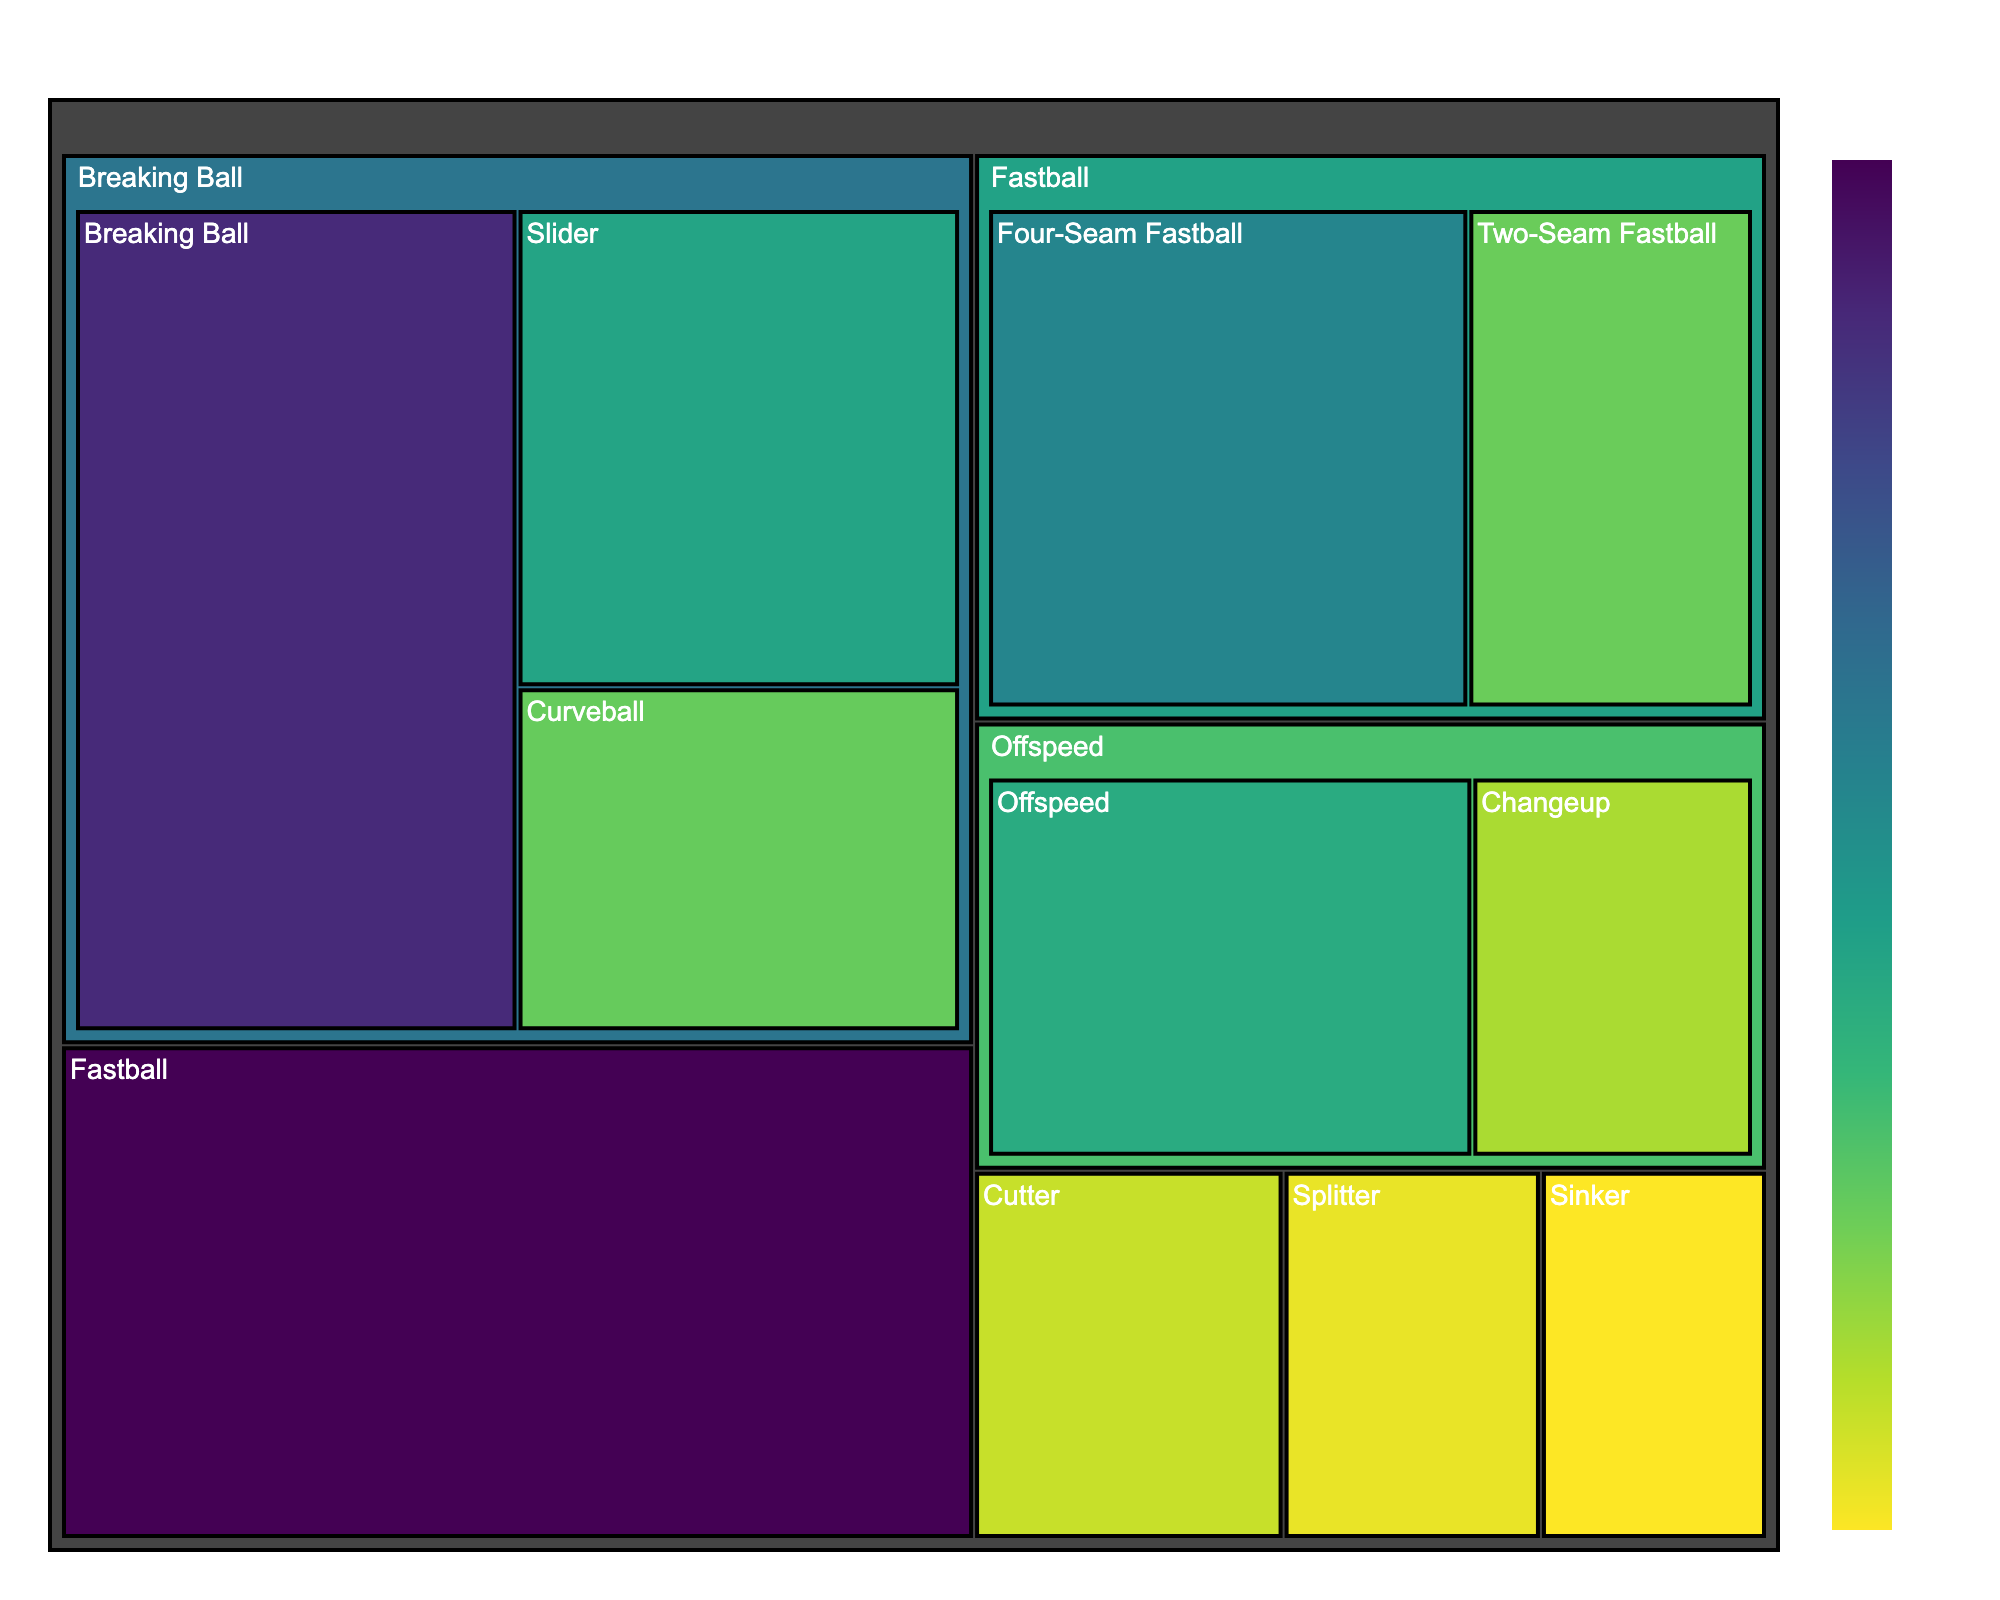How many pitch types are there in total? The treemap shows different pitch types each represented as a distinct block. Count all different blocks showing the names of pitch types.
Answer: 11 Which pitch type has the highest frequency? Look at the block with the largest area and check the corresponding pitch type label, then verify it has the highest frequency percentage in the hover data.
Answer: Fastball What is the frequency difference between the most frequent pitch type and the least frequent pitch type? Identify the most frequent pitch type (Fastball: 35.2%) and the least frequent pitch type (Sinker: 6.5%) and subtract the smaller percentage from the larger one: 35.2 - 6.5.
Answer: 28.7% Which pitch type under 'Breaking Ball' has a higher frequency? Look at the Breaking Ball section of the treemap and compare the frequencies of Slider (18.5%) and Curveball (13.3%). Since 18.5 > 13.3, Slider has a higher frequency.
Answer: Slider What percentage of pitches are either Changeup or Splitter? Add the frequencies of Changeup (10.2%) and Splitter (7.4%) to get the total: 10.2 +7.4.
Answer: 17.6% How does the frequency of Four-Seam Fastball compare to the total frequency of Offspeed pitches? Four-Seam Fastball has a frequency of 22.1%. Summing the frequencies of Offspeed pitches (Changeup: 10.2%, Splitter: 7.4%) gives a total of 17.6%. Compare the two values (22.1 is greater than 17.6).
Answer: Four-Seam Fastball has higher frequency Which category does Cutter belong to and what's its frequency? Locate the block labeled Cutter in the treemap and note which parent category it falls under and its frequency which can be verified from the hover data.
Answer: Cutter is uncategorized; frequency is 8.9% What's the combined frequency of all Fastball-related pitch types? Identify the frequencies of all Fastball-related pitch types (Four-Seam Fastball: 22.1%, Two-Seam Fastball: 13.1%) and sum them up with the Fastball category itself: 22.1 + 13.1 + 35.2 (counting Fastball twice is redundant; directly use the smaller categories): 35.2.
Answer: 35.2% If you were to group the categories into three larger types (Fastball, Breaking Ball, and Offspeed), which group has the highest total frequency? Sum up the frequencies in each group: Fastball (35.2%), Breaking Ball (Slider: 18.5%, Curveball: 13.3%), Offspeed (Changeup: 10.2%, Splitter: 7.4%). Compare the totals to deduce that Fastball has the highest: Fastball 35.2%, Breaking Ball 31.8%, and Offspeed 17.6%.
Answer: Fastball What fraction of the total pitch types does Sinker represent? The total frequency can be calculated by summing all individual frequencies: 35.2 + 22.1 + 13.1 + 31.8 + 18.5 + 13.3 + 17.6 + 10.2 + 7.4 + 8.9 + 6.5; then determine the fraction for Sinker (6.5%). Simplified it would be: 6.5 / 184.6.
Answer: Approximately 0.035 